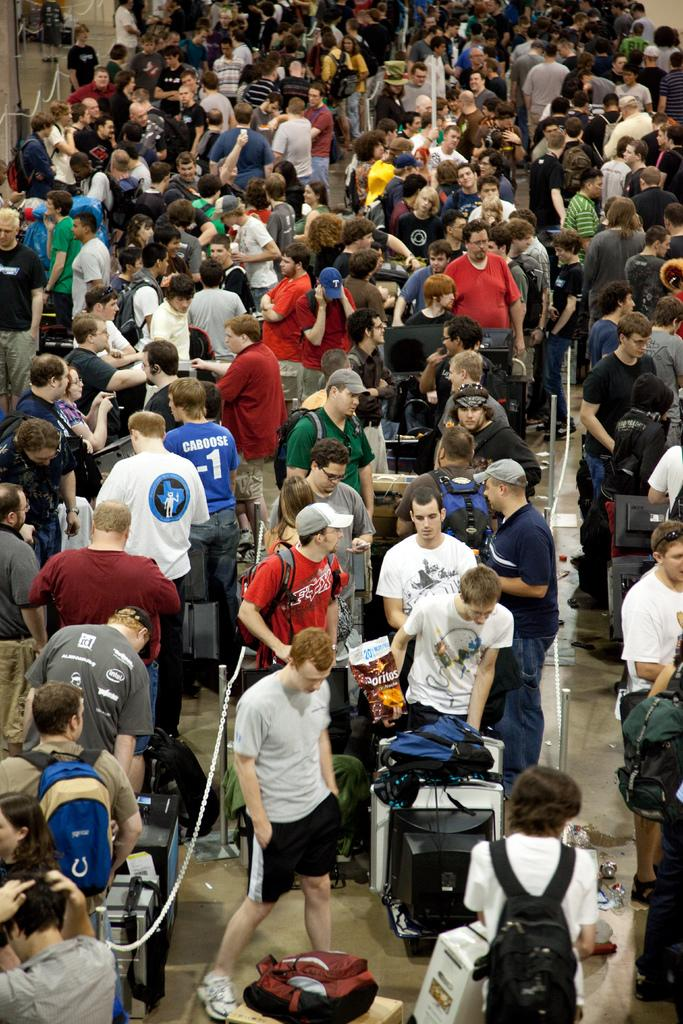How many people are in the image? There is a group of people standing in the image. What is the surface the people are standing on? The people are standing on the floor. What objects can be seen with chains in the image? There are poles with chains in the image. What type of electronic devices are present in the image? There are monitors on tables in the image. What item is on the floor in the image? There is a bag on the floor in the image. What type of throat medicine is visible on the table in the image? There is no throat medicine present in the image. What type of laborer is working in the image? There is no laborer present in the image. 